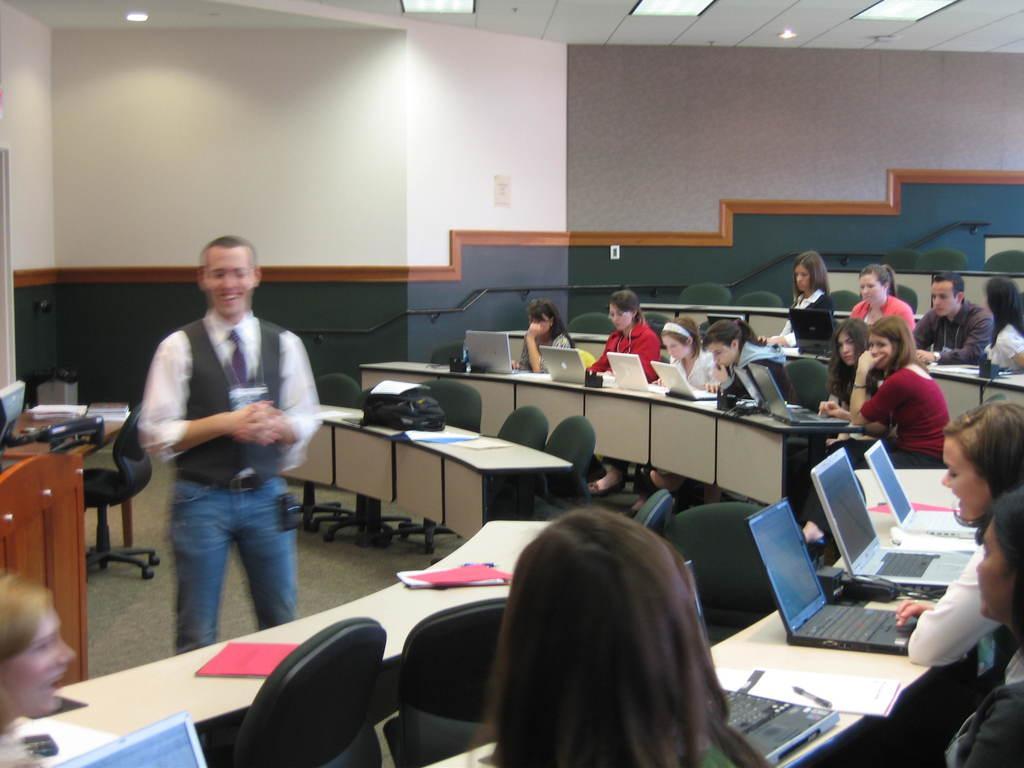In one or two sentences, can you explain what this image depicts? As we can see in the image there is a white color wall, few people over here and there are tables. On tables there are laptops, bags, books and papers. 